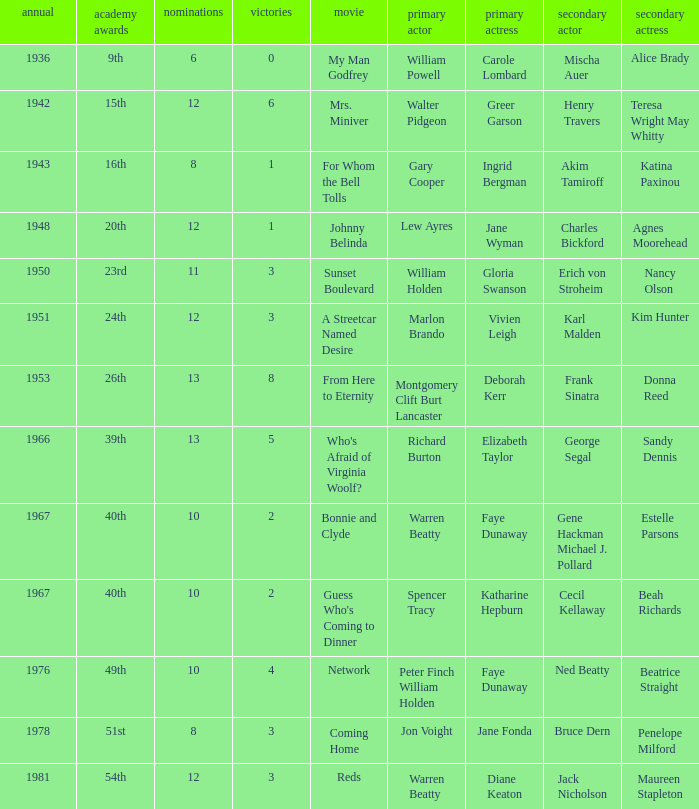Who was the leading actor in the film with a supporting actor named Cecil Kellaway? Spencer Tracy. 